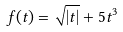<formula> <loc_0><loc_0><loc_500><loc_500>f ( t ) = \sqrt { | t | } + 5 t ^ { 3 }</formula> 